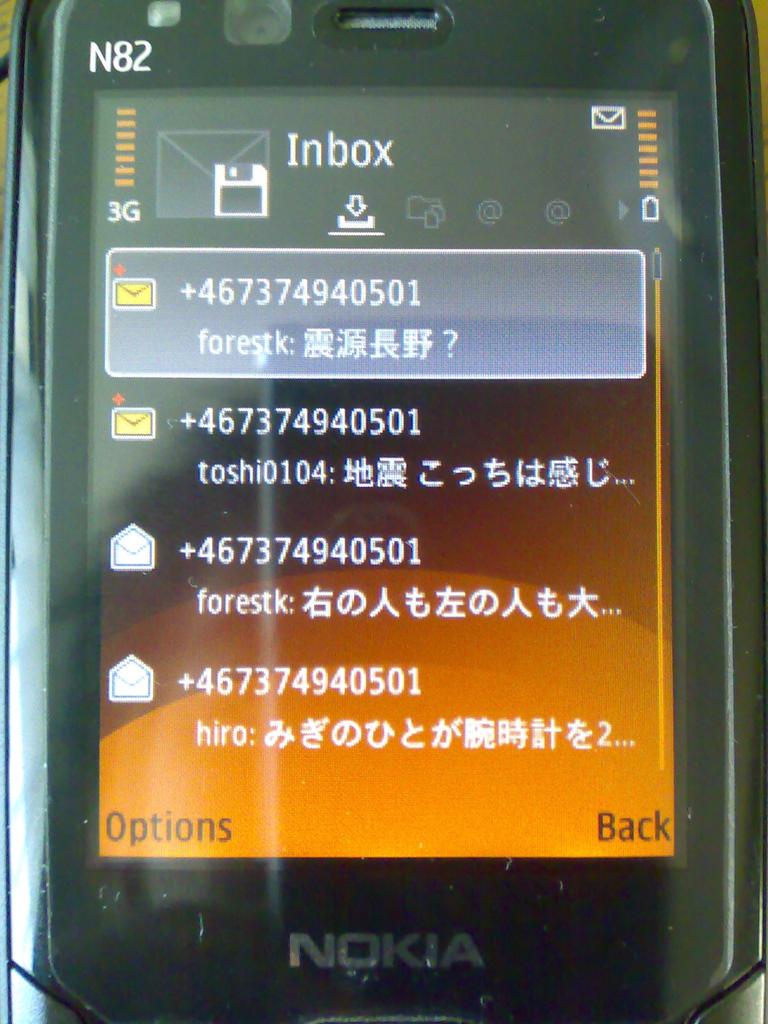What brand of phone is bring used?
Offer a terse response. Nokia. Is this the inbox or outbox shown on the screen?
Your response must be concise. Inbox. 